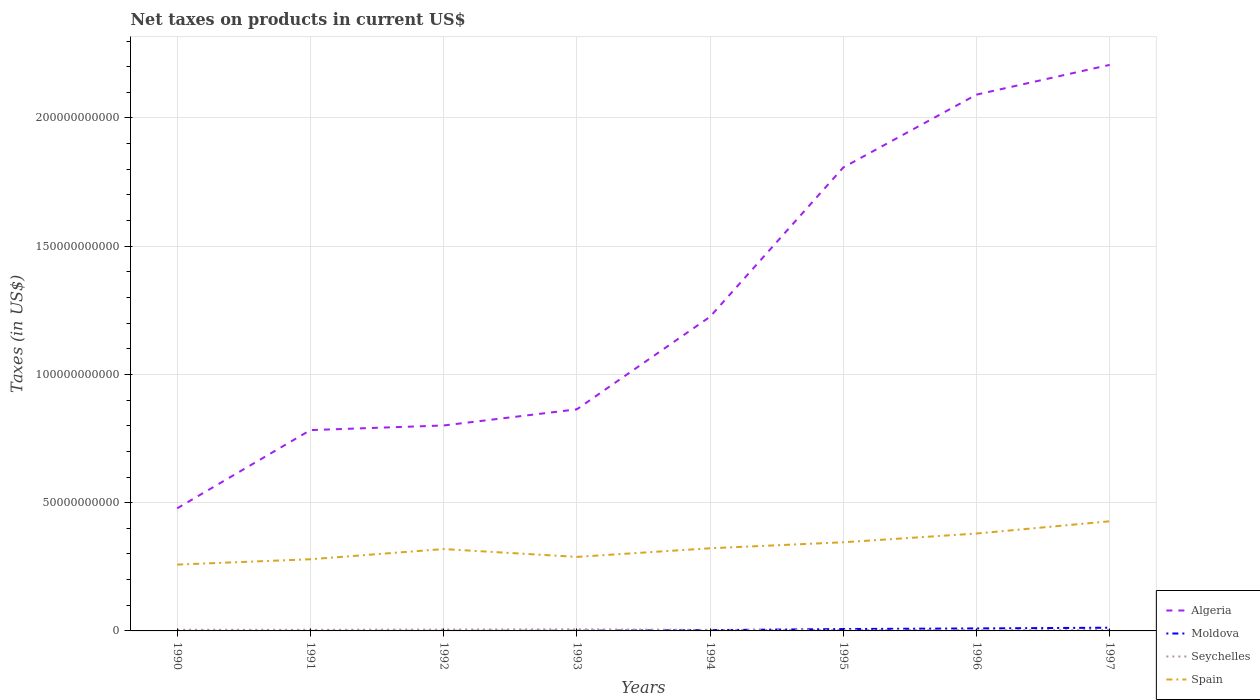Does the line corresponding to Algeria intersect with the line corresponding to Seychelles?
Offer a terse response. No. Is the number of lines equal to the number of legend labels?
Ensure brevity in your answer.  Yes. Across all years, what is the maximum net taxes on products in Moldova?
Your response must be concise. 7.11e+05. In which year was the net taxes on products in Algeria maximum?
Your answer should be very brief. 1990. What is the total net taxes on products in Moldova in the graph?
Give a very brief answer. -9.57e+08. What is the difference between the highest and the second highest net taxes on products in Seychelles?
Make the answer very short. 3.41e+08. Is the net taxes on products in Algeria strictly greater than the net taxes on products in Spain over the years?
Make the answer very short. No. What is the difference between two consecutive major ticks on the Y-axis?
Keep it short and to the point. 5.00e+1. Are the values on the major ticks of Y-axis written in scientific E-notation?
Provide a succinct answer. No. Does the graph contain any zero values?
Your answer should be very brief. No. How are the legend labels stacked?
Offer a very short reply. Vertical. What is the title of the graph?
Provide a succinct answer. Net taxes on products in current US$. What is the label or title of the Y-axis?
Give a very brief answer. Taxes (in US$). What is the Taxes (in US$) of Algeria in 1990?
Give a very brief answer. 4.78e+1. What is the Taxes (in US$) in Moldova in 1990?
Provide a short and direct response. 7.11e+05. What is the Taxes (in US$) of Seychelles in 1990?
Provide a short and direct response. 4.66e+08. What is the Taxes (in US$) of Spain in 1990?
Give a very brief answer. 2.59e+1. What is the Taxes (in US$) in Algeria in 1991?
Make the answer very short. 7.83e+1. What is the Taxes (in US$) of Moldova in 1991?
Provide a short and direct response. 2.50e+06. What is the Taxes (in US$) in Seychelles in 1991?
Provide a short and direct response. 4.37e+08. What is the Taxes (in US$) of Spain in 1991?
Your answer should be compact. 2.79e+1. What is the Taxes (in US$) in Algeria in 1992?
Offer a very short reply. 8.01e+1. What is the Taxes (in US$) of Moldova in 1992?
Provide a short and direct response. 1.50e+07. What is the Taxes (in US$) of Seychelles in 1992?
Offer a terse response. 5.37e+08. What is the Taxes (in US$) in Spain in 1992?
Give a very brief answer. 3.19e+1. What is the Taxes (in US$) in Algeria in 1993?
Offer a terse response. 8.64e+1. What is the Taxes (in US$) in Moldova in 1993?
Your answer should be very brief. 7.31e+07. What is the Taxes (in US$) in Seychelles in 1993?
Your answer should be very brief. 6.43e+08. What is the Taxes (in US$) of Spain in 1993?
Offer a very short reply. 2.89e+1. What is the Taxes (in US$) of Algeria in 1994?
Your response must be concise. 1.22e+11. What is the Taxes (in US$) of Moldova in 1994?
Provide a short and direct response. 3.12e+08. What is the Taxes (in US$) in Seychelles in 1994?
Provide a succinct answer. 3.99e+08. What is the Taxes (in US$) of Spain in 1994?
Provide a succinct answer. 3.22e+1. What is the Taxes (in US$) of Algeria in 1995?
Offer a very short reply. 1.81e+11. What is the Taxes (in US$) of Moldova in 1995?
Offer a very short reply. 7.36e+08. What is the Taxes (in US$) in Seychelles in 1995?
Offer a very short reply. 3.02e+08. What is the Taxes (in US$) in Spain in 1995?
Offer a very short reply. 3.46e+1. What is the Taxes (in US$) in Algeria in 1996?
Your answer should be very brief. 2.09e+11. What is the Taxes (in US$) in Moldova in 1996?
Your answer should be compact. 9.72e+08. What is the Taxes (in US$) of Seychelles in 1996?
Keep it short and to the point. 3.06e+08. What is the Taxes (in US$) of Spain in 1996?
Keep it short and to the point. 3.80e+1. What is the Taxes (in US$) of Algeria in 1997?
Offer a terse response. 2.21e+11. What is the Taxes (in US$) in Moldova in 1997?
Give a very brief answer. 1.25e+09. What is the Taxes (in US$) in Seychelles in 1997?
Ensure brevity in your answer.  3.22e+08. What is the Taxes (in US$) in Spain in 1997?
Your response must be concise. 4.27e+1. Across all years, what is the maximum Taxes (in US$) of Algeria?
Your response must be concise. 2.21e+11. Across all years, what is the maximum Taxes (in US$) in Moldova?
Make the answer very short. 1.25e+09. Across all years, what is the maximum Taxes (in US$) in Seychelles?
Ensure brevity in your answer.  6.43e+08. Across all years, what is the maximum Taxes (in US$) in Spain?
Your answer should be very brief. 4.27e+1. Across all years, what is the minimum Taxes (in US$) in Algeria?
Keep it short and to the point. 4.78e+1. Across all years, what is the minimum Taxes (in US$) in Moldova?
Your response must be concise. 7.11e+05. Across all years, what is the minimum Taxes (in US$) of Seychelles?
Offer a very short reply. 3.02e+08. Across all years, what is the minimum Taxes (in US$) in Spain?
Provide a short and direct response. 2.59e+1. What is the total Taxes (in US$) of Algeria in the graph?
Keep it short and to the point. 1.03e+12. What is the total Taxes (in US$) of Moldova in the graph?
Offer a terse response. 3.36e+09. What is the total Taxes (in US$) in Seychelles in the graph?
Offer a very short reply. 3.41e+09. What is the total Taxes (in US$) in Spain in the graph?
Make the answer very short. 2.62e+11. What is the difference between the Taxes (in US$) of Algeria in 1990 and that in 1991?
Offer a very short reply. -3.05e+1. What is the difference between the Taxes (in US$) in Moldova in 1990 and that in 1991?
Your answer should be compact. -1.79e+06. What is the difference between the Taxes (in US$) in Seychelles in 1990 and that in 1991?
Provide a succinct answer. 2.95e+07. What is the difference between the Taxes (in US$) in Spain in 1990 and that in 1991?
Your answer should be very brief. -2.08e+09. What is the difference between the Taxes (in US$) of Algeria in 1990 and that in 1992?
Offer a terse response. -3.23e+1. What is the difference between the Taxes (in US$) in Moldova in 1990 and that in 1992?
Give a very brief answer. -1.43e+07. What is the difference between the Taxes (in US$) in Seychelles in 1990 and that in 1992?
Your response must be concise. -7.12e+07. What is the difference between the Taxes (in US$) of Spain in 1990 and that in 1992?
Provide a succinct answer. -6.06e+09. What is the difference between the Taxes (in US$) of Algeria in 1990 and that in 1993?
Keep it short and to the point. -3.86e+1. What is the difference between the Taxes (in US$) of Moldova in 1990 and that in 1993?
Provide a short and direct response. -7.24e+07. What is the difference between the Taxes (in US$) in Seychelles in 1990 and that in 1993?
Your answer should be compact. -1.76e+08. What is the difference between the Taxes (in US$) in Spain in 1990 and that in 1993?
Provide a short and direct response. -3.00e+09. What is the difference between the Taxes (in US$) of Algeria in 1990 and that in 1994?
Ensure brevity in your answer.  -7.47e+1. What is the difference between the Taxes (in US$) in Moldova in 1990 and that in 1994?
Offer a terse response. -3.11e+08. What is the difference between the Taxes (in US$) of Seychelles in 1990 and that in 1994?
Ensure brevity in your answer.  6.71e+07. What is the difference between the Taxes (in US$) in Spain in 1990 and that in 1994?
Your response must be concise. -6.36e+09. What is the difference between the Taxes (in US$) in Algeria in 1990 and that in 1995?
Offer a very short reply. -1.33e+11. What is the difference between the Taxes (in US$) in Moldova in 1990 and that in 1995?
Ensure brevity in your answer.  -7.35e+08. What is the difference between the Taxes (in US$) of Seychelles in 1990 and that in 1995?
Offer a very short reply. 1.64e+08. What is the difference between the Taxes (in US$) in Spain in 1990 and that in 1995?
Offer a very short reply. -8.70e+09. What is the difference between the Taxes (in US$) of Algeria in 1990 and that in 1996?
Your answer should be very brief. -1.61e+11. What is the difference between the Taxes (in US$) in Moldova in 1990 and that in 1996?
Ensure brevity in your answer.  -9.71e+08. What is the difference between the Taxes (in US$) of Seychelles in 1990 and that in 1996?
Give a very brief answer. 1.60e+08. What is the difference between the Taxes (in US$) of Spain in 1990 and that in 1996?
Offer a very short reply. -1.21e+1. What is the difference between the Taxes (in US$) of Algeria in 1990 and that in 1997?
Make the answer very short. -1.73e+11. What is the difference between the Taxes (in US$) of Moldova in 1990 and that in 1997?
Make the answer very short. -1.25e+09. What is the difference between the Taxes (in US$) of Seychelles in 1990 and that in 1997?
Keep it short and to the point. 1.44e+08. What is the difference between the Taxes (in US$) of Spain in 1990 and that in 1997?
Provide a succinct answer. -1.69e+1. What is the difference between the Taxes (in US$) in Algeria in 1991 and that in 1992?
Provide a short and direct response. -1.80e+09. What is the difference between the Taxes (in US$) of Moldova in 1991 and that in 1992?
Keep it short and to the point. -1.25e+07. What is the difference between the Taxes (in US$) of Seychelles in 1991 and that in 1992?
Ensure brevity in your answer.  -1.01e+08. What is the difference between the Taxes (in US$) in Spain in 1991 and that in 1992?
Provide a succinct answer. -3.97e+09. What is the difference between the Taxes (in US$) in Algeria in 1991 and that in 1993?
Provide a succinct answer. -8.10e+09. What is the difference between the Taxes (in US$) of Moldova in 1991 and that in 1993?
Keep it short and to the point. -7.06e+07. What is the difference between the Taxes (in US$) of Seychelles in 1991 and that in 1993?
Give a very brief answer. -2.06e+08. What is the difference between the Taxes (in US$) in Spain in 1991 and that in 1993?
Give a very brief answer. -9.21e+08. What is the difference between the Taxes (in US$) in Algeria in 1991 and that in 1994?
Your answer should be compact. -4.42e+1. What is the difference between the Taxes (in US$) in Moldova in 1991 and that in 1994?
Your response must be concise. -3.09e+08. What is the difference between the Taxes (in US$) in Seychelles in 1991 and that in 1994?
Give a very brief answer. 3.76e+07. What is the difference between the Taxes (in US$) of Spain in 1991 and that in 1994?
Give a very brief answer. -4.28e+09. What is the difference between the Taxes (in US$) in Algeria in 1991 and that in 1995?
Provide a succinct answer. -1.02e+11. What is the difference between the Taxes (in US$) of Moldova in 1991 and that in 1995?
Offer a terse response. -7.33e+08. What is the difference between the Taxes (in US$) in Seychelles in 1991 and that in 1995?
Offer a terse response. 1.35e+08. What is the difference between the Taxes (in US$) in Spain in 1991 and that in 1995?
Ensure brevity in your answer.  -6.62e+09. What is the difference between the Taxes (in US$) of Algeria in 1991 and that in 1996?
Your answer should be compact. -1.31e+11. What is the difference between the Taxes (in US$) in Moldova in 1991 and that in 1996?
Provide a short and direct response. -9.69e+08. What is the difference between the Taxes (in US$) of Seychelles in 1991 and that in 1996?
Ensure brevity in your answer.  1.30e+08. What is the difference between the Taxes (in US$) in Spain in 1991 and that in 1996?
Ensure brevity in your answer.  -1.00e+1. What is the difference between the Taxes (in US$) in Algeria in 1991 and that in 1997?
Your answer should be compact. -1.42e+11. What is the difference between the Taxes (in US$) in Moldova in 1991 and that in 1997?
Provide a succinct answer. -1.25e+09. What is the difference between the Taxes (in US$) in Seychelles in 1991 and that in 1997?
Your response must be concise. 1.15e+08. What is the difference between the Taxes (in US$) of Spain in 1991 and that in 1997?
Your answer should be very brief. -1.48e+1. What is the difference between the Taxes (in US$) in Algeria in 1992 and that in 1993?
Keep it short and to the point. -6.30e+09. What is the difference between the Taxes (in US$) in Moldova in 1992 and that in 1993?
Offer a terse response. -5.81e+07. What is the difference between the Taxes (in US$) of Seychelles in 1992 and that in 1993?
Provide a short and direct response. -1.05e+08. What is the difference between the Taxes (in US$) of Spain in 1992 and that in 1993?
Ensure brevity in your answer.  3.05e+09. What is the difference between the Taxes (in US$) in Algeria in 1992 and that in 1994?
Provide a short and direct response. -4.24e+1. What is the difference between the Taxes (in US$) of Moldova in 1992 and that in 1994?
Provide a succinct answer. -2.97e+08. What is the difference between the Taxes (in US$) in Seychelles in 1992 and that in 1994?
Give a very brief answer. 1.38e+08. What is the difference between the Taxes (in US$) in Spain in 1992 and that in 1994?
Provide a succinct answer. -3.05e+08. What is the difference between the Taxes (in US$) of Algeria in 1992 and that in 1995?
Your response must be concise. -1.01e+11. What is the difference between the Taxes (in US$) of Moldova in 1992 and that in 1995?
Offer a very short reply. -7.21e+08. What is the difference between the Taxes (in US$) of Seychelles in 1992 and that in 1995?
Your response must be concise. 2.35e+08. What is the difference between the Taxes (in US$) in Spain in 1992 and that in 1995?
Provide a short and direct response. -2.65e+09. What is the difference between the Taxes (in US$) of Algeria in 1992 and that in 1996?
Provide a short and direct response. -1.29e+11. What is the difference between the Taxes (in US$) in Moldova in 1992 and that in 1996?
Your response must be concise. -9.57e+08. What is the difference between the Taxes (in US$) in Seychelles in 1992 and that in 1996?
Give a very brief answer. 2.31e+08. What is the difference between the Taxes (in US$) of Spain in 1992 and that in 1996?
Your response must be concise. -6.05e+09. What is the difference between the Taxes (in US$) in Algeria in 1992 and that in 1997?
Ensure brevity in your answer.  -1.41e+11. What is the difference between the Taxes (in US$) in Moldova in 1992 and that in 1997?
Keep it short and to the point. -1.24e+09. What is the difference between the Taxes (in US$) of Seychelles in 1992 and that in 1997?
Your answer should be compact. 2.16e+08. What is the difference between the Taxes (in US$) in Spain in 1992 and that in 1997?
Offer a very short reply. -1.08e+1. What is the difference between the Taxes (in US$) of Algeria in 1993 and that in 1994?
Provide a short and direct response. -3.61e+1. What is the difference between the Taxes (in US$) of Moldova in 1993 and that in 1994?
Your response must be concise. -2.38e+08. What is the difference between the Taxes (in US$) of Seychelles in 1993 and that in 1994?
Provide a succinct answer. 2.44e+08. What is the difference between the Taxes (in US$) of Spain in 1993 and that in 1994?
Your answer should be compact. -3.36e+09. What is the difference between the Taxes (in US$) in Algeria in 1993 and that in 1995?
Provide a short and direct response. -9.43e+1. What is the difference between the Taxes (in US$) of Moldova in 1993 and that in 1995?
Provide a short and direct response. -6.62e+08. What is the difference between the Taxes (in US$) of Seychelles in 1993 and that in 1995?
Provide a succinct answer. 3.41e+08. What is the difference between the Taxes (in US$) in Spain in 1993 and that in 1995?
Offer a very short reply. -5.70e+09. What is the difference between the Taxes (in US$) in Algeria in 1993 and that in 1996?
Your answer should be compact. -1.23e+11. What is the difference between the Taxes (in US$) in Moldova in 1993 and that in 1996?
Provide a short and direct response. -8.99e+08. What is the difference between the Taxes (in US$) in Seychelles in 1993 and that in 1996?
Offer a terse response. 3.36e+08. What is the difference between the Taxes (in US$) in Spain in 1993 and that in 1996?
Your answer should be very brief. -9.11e+09. What is the difference between the Taxes (in US$) of Algeria in 1993 and that in 1997?
Your answer should be compact. -1.34e+11. What is the difference between the Taxes (in US$) in Moldova in 1993 and that in 1997?
Give a very brief answer. -1.18e+09. What is the difference between the Taxes (in US$) in Seychelles in 1993 and that in 1997?
Your answer should be compact. 3.21e+08. What is the difference between the Taxes (in US$) of Spain in 1993 and that in 1997?
Offer a very short reply. -1.39e+1. What is the difference between the Taxes (in US$) in Algeria in 1994 and that in 1995?
Provide a short and direct response. -5.82e+1. What is the difference between the Taxes (in US$) in Moldova in 1994 and that in 1995?
Keep it short and to the point. -4.24e+08. What is the difference between the Taxes (in US$) in Seychelles in 1994 and that in 1995?
Provide a succinct answer. 9.71e+07. What is the difference between the Taxes (in US$) in Spain in 1994 and that in 1995?
Your response must be concise. -2.34e+09. What is the difference between the Taxes (in US$) in Algeria in 1994 and that in 1996?
Offer a very short reply. -8.66e+1. What is the difference between the Taxes (in US$) of Moldova in 1994 and that in 1996?
Give a very brief answer. -6.60e+08. What is the difference between the Taxes (in US$) of Seychelles in 1994 and that in 1996?
Your answer should be very brief. 9.28e+07. What is the difference between the Taxes (in US$) in Spain in 1994 and that in 1996?
Make the answer very short. -5.75e+09. What is the difference between the Taxes (in US$) of Algeria in 1994 and that in 1997?
Your answer should be very brief. -9.82e+1. What is the difference between the Taxes (in US$) in Moldova in 1994 and that in 1997?
Keep it short and to the point. -9.41e+08. What is the difference between the Taxes (in US$) in Seychelles in 1994 and that in 1997?
Provide a short and direct response. 7.74e+07. What is the difference between the Taxes (in US$) of Spain in 1994 and that in 1997?
Keep it short and to the point. -1.05e+1. What is the difference between the Taxes (in US$) in Algeria in 1995 and that in 1996?
Your answer should be compact. -2.84e+1. What is the difference between the Taxes (in US$) in Moldova in 1995 and that in 1996?
Give a very brief answer. -2.36e+08. What is the difference between the Taxes (in US$) in Seychelles in 1995 and that in 1996?
Your response must be concise. -4.30e+06. What is the difference between the Taxes (in US$) in Spain in 1995 and that in 1996?
Make the answer very short. -3.41e+09. What is the difference between the Taxes (in US$) of Algeria in 1995 and that in 1997?
Offer a very short reply. -4.00e+1. What is the difference between the Taxes (in US$) in Moldova in 1995 and that in 1997?
Keep it short and to the point. -5.17e+08. What is the difference between the Taxes (in US$) in Seychelles in 1995 and that in 1997?
Your answer should be compact. -1.97e+07. What is the difference between the Taxes (in US$) of Spain in 1995 and that in 1997?
Provide a succinct answer. -8.18e+09. What is the difference between the Taxes (in US$) of Algeria in 1996 and that in 1997?
Ensure brevity in your answer.  -1.16e+1. What is the difference between the Taxes (in US$) in Moldova in 1996 and that in 1997?
Make the answer very short. -2.81e+08. What is the difference between the Taxes (in US$) in Seychelles in 1996 and that in 1997?
Provide a short and direct response. -1.54e+07. What is the difference between the Taxes (in US$) in Spain in 1996 and that in 1997?
Make the answer very short. -4.78e+09. What is the difference between the Taxes (in US$) in Algeria in 1990 and the Taxes (in US$) in Moldova in 1991?
Your response must be concise. 4.78e+1. What is the difference between the Taxes (in US$) of Algeria in 1990 and the Taxes (in US$) of Seychelles in 1991?
Ensure brevity in your answer.  4.74e+1. What is the difference between the Taxes (in US$) of Algeria in 1990 and the Taxes (in US$) of Spain in 1991?
Provide a short and direct response. 1.99e+1. What is the difference between the Taxes (in US$) of Moldova in 1990 and the Taxes (in US$) of Seychelles in 1991?
Make the answer very short. -4.36e+08. What is the difference between the Taxes (in US$) in Moldova in 1990 and the Taxes (in US$) in Spain in 1991?
Make the answer very short. -2.79e+1. What is the difference between the Taxes (in US$) of Seychelles in 1990 and the Taxes (in US$) of Spain in 1991?
Your response must be concise. -2.75e+1. What is the difference between the Taxes (in US$) in Algeria in 1990 and the Taxes (in US$) in Moldova in 1992?
Keep it short and to the point. 4.78e+1. What is the difference between the Taxes (in US$) in Algeria in 1990 and the Taxes (in US$) in Seychelles in 1992?
Give a very brief answer. 4.73e+1. What is the difference between the Taxes (in US$) of Algeria in 1990 and the Taxes (in US$) of Spain in 1992?
Keep it short and to the point. 1.59e+1. What is the difference between the Taxes (in US$) in Moldova in 1990 and the Taxes (in US$) in Seychelles in 1992?
Provide a succinct answer. -5.37e+08. What is the difference between the Taxes (in US$) of Moldova in 1990 and the Taxes (in US$) of Spain in 1992?
Your answer should be very brief. -3.19e+1. What is the difference between the Taxes (in US$) in Seychelles in 1990 and the Taxes (in US$) in Spain in 1992?
Offer a very short reply. -3.15e+1. What is the difference between the Taxes (in US$) in Algeria in 1990 and the Taxes (in US$) in Moldova in 1993?
Keep it short and to the point. 4.77e+1. What is the difference between the Taxes (in US$) of Algeria in 1990 and the Taxes (in US$) of Seychelles in 1993?
Offer a very short reply. 4.72e+1. What is the difference between the Taxes (in US$) of Algeria in 1990 and the Taxes (in US$) of Spain in 1993?
Make the answer very short. 1.89e+1. What is the difference between the Taxes (in US$) in Moldova in 1990 and the Taxes (in US$) in Seychelles in 1993?
Your answer should be compact. -6.42e+08. What is the difference between the Taxes (in US$) in Moldova in 1990 and the Taxes (in US$) in Spain in 1993?
Provide a short and direct response. -2.89e+1. What is the difference between the Taxes (in US$) of Seychelles in 1990 and the Taxes (in US$) of Spain in 1993?
Offer a terse response. -2.84e+1. What is the difference between the Taxes (in US$) in Algeria in 1990 and the Taxes (in US$) in Moldova in 1994?
Your answer should be very brief. 4.75e+1. What is the difference between the Taxes (in US$) in Algeria in 1990 and the Taxes (in US$) in Seychelles in 1994?
Ensure brevity in your answer.  4.74e+1. What is the difference between the Taxes (in US$) in Algeria in 1990 and the Taxes (in US$) in Spain in 1994?
Offer a terse response. 1.56e+1. What is the difference between the Taxes (in US$) in Moldova in 1990 and the Taxes (in US$) in Seychelles in 1994?
Provide a succinct answer. -3.98e+08. What is the difference between the Taxes (in US$) in Moldova in 1990 and the Taxes (in US$) in Spain in 1994?
Your answer should be very brief. -3.22e+1. What is the difference between the Taxes (in US$) in Seychelles in 1990 and the Taxes (in US$) in Spain in 1994?
Provide a short and direct response. -3.18e+1. What is the difference between the Taxes (in US$) in Algeria in 1990 and the Taxes (in US$) in Moldova in 1995?
Make the answer very short. 4.71e+1. What is the difference between the Taxes (in US$) of Algeria in 1990 and the Taxes (in US$) of Seychelles in 1995?
Make the answer very short. 4.75e+1. What is the difference between the Taxes (in US$) of Algeria in 1990 and the Taxes (in US$) of Spain in 1995?
Provide a succinct answer. 1.32e+1. What is the difference between the Taxes (in US$) in Moldova in 1990 and the Taxes (in US$) in Seychelles in 1995?
Your response must be concise. -3.01e+08. What is the difference between the Taxes (in US$) of Moldova in 1990 and the Taxes (in US$) of Spain in 1995?
Your answer should be compact. -3.46e+1. What is the difference between the Taxes (in US$) in Seychelles in 1990 and the Taxes (in US$) in Spain in 1995?
Provide a succinct answer. -3.41e+1. What is the difference between the Taxes (in US$) of Algeria in 1990 and the Taxes (in US$) of Moldova in 1996?
Make the answer very short. 4.68e+1. What is the difference between the Taxes (in US$) of Algeria in 1990 and the Taxes (in US$) of Seychelles in 1996?
Your response must be concise. 4.75e+1. What is the difference between the Taxes (in US$) in Algeria in 1990 and the Taxes (in US$) in Spain in 1996?
Offer a terse response. 9.83e+09. What is the difference between the Taxes (in US$) of Moldova in 1990 and the Taxes (in US$) of Seychelles in 1996?
Your answer should be very brief. -3.06e+08. What is the difference between the Taxes (in US$) of Moldova in 1990 and the Taxes (in US$) of Spain in 1996?
Make the answer very short. -3.80e+1. What is the difference between the Taxes (in US$) in Seychelles in 1990 and the Taxes (in US$) in Spain in 1996?
Your answer should be very brief. -3.75e+1. What is the difference between the Taxes (in US$) in Algeria in 1990 and the Taxes (in US$) in Moldova in 1997?
Provide a succinct answer. 4.65e+1. What is the difference between the Taxes (in US$) of Algeria in 1990 and the Taxes (in US$) of Seychelles in 1997?
Make the answer very short. 4.75e+1. What is the difference between the Taxes (in US$) of Algeria in 1990 and the Taxes (in US$) of Spain in 1997?
Your answer should be very brief. 5.05e+09. What is the difference between the Taxes (in US$) in Moldova in 1990 and the Taxes (in US$) in Seychelles in 1997?
Your response must be concise. -3.21e+08. What is the difference between the Taxes (in US$) of Moldova in 1990 and the Taxes (in US$) of Spain in 1997?
Give a very brief answer. -4.27e+1. What is the difference between the Taxes (in US$) of Seychelles in 1990 and the Taxes (in US$) of Spain in 1997?
Keep it short and to the point. -4.23e+1. What is the difference between the Taxes (in US$) of Algeria in 1991 and the Taxes (in US$) of Moldova in 1992?
Your response must be concise. 7.83e+1. What is the difference between the Taxes (in US$) in Algeria in 1991 and the Taxes (in US$) in Seychelles in 1992?
Your response must be concise. 7.78e+1. What is the difference between the Taxes (in US$) of Algeria in 1991 and the Taxes (in US$) of Spain in 1992?
Offer a terse response. 4.64e+1. What is the difference between the Taxes (in US$) in Moldova in 1991 and the Taxes (in US$) in Seychelles in 1992?
Make the answer very short. -5.35e+08. What is the difference between the Taxes (in US$) of Moldova in 1991 and the Taxes (in US$) of Spain in 1992?
Make the answer very short. -3.19e+1. What is the difference between the Taxes (in US$) in Seychelles in 1991 and the Taxes (in US$) in Spain in 1992?
Offer a terse response. -3.15e+1. What is the difference between the Taxes (in US$) in Algeria in 1991 and the Taxes (in US$) in Moldova in 1993?
Your response must be concise. 7.82e+1. What is the difference between the Taxes (in US$) in Algeria in 1991 and the Taxes (in US$) in Seychelles in 1993?
Ensure brevity in your answer.  7.77e+1. What is the difference between the Taxes (in US$) of Algeria in 1991 and the Taxes (in US$) of Spain in 1993?
Ensure brevity in your answer.  4.94e+1. What is the difference between the Taxes (in US$) in Moldova in 1991 and the Taxes (in US$) in Seychelles in 1993?
Give a very brief answer. -6.40e+08. What is the difference between the Taxes (in US$) in Moldova in 1991 and the Taxes (in US$) in Spain in 1993?
Make the answer very short. -2.89e+1. What is the difference between the Taxes (in US$) in Seychelles in 1991 and the Taxes (in US$) in Spain in 1993?
Provide a short and direct response. -2.84e+1. What is the difference between the Taxes (in US$) in Algeria in 1991 and the Taxes (in US$) in Moldova in 1994?
Give a very brief answer. 7.80e+1. What is the difference between the Taxes (in US$) in Algeria in 1991 and the Taxes (in US$) in Seychelles in 1994?
Give a very brief answer. 7.79e+1. What is the difference between the Taxes (in US$) of Algeria in 1991 and the Taxes (in US$) of Spain in 1994?
Offer a terse response. 4.61e+1. What is the difference between the Taxes (in US$) in Moldova in 1991 and the Taxes (in US$) in Seychelles in 1994?
Offer a terse response. -3.97e+08. What is the difference between the Taxes (in US$) in Moldova in 1991 and the Taxes (in US$) in Spain in 1994?
Provide a succinct answer. -3.22e+1. What is the difference between the Taxes (in US$) of Seychelles in 1991 and the Taxes (in US$) of Spain in 1994?
Your response must be concise. -3.18e+1. What is the difference between the Taxes (in US$) in Algeria in 1991 and the Taxes (in US$) in Moldova in 1995?
Offer a terse response. 7.76e+1. What is the difference between the Taxes (in US$) in Algeria in 1991 and the Taxes (in US$) in Seychelles in 1995?
Offer a very short reply. 7.80e+1. What is the difference between the Taxes (in US$) of Algeria in 1991 and the Taxes (in US$) of Spain in 1995?
Your response must be concise. 4.37e+1. What is the difference between the Taxes (in US$) in Moldova in 1991 and the Taxes (in US$) in Seychelles in 1995?
Ensure brevity in your answer.  -3.00e+08. What is the difference between the Taxes (in US$) of Moldova in 1991 and the Taxes (in US$) of Spain in 1995?
Offer a terse response. -3.46e+1. What is the difference between the Taxes (in US$) in Seychelles in 1991 and the Taxes (in US$) in Spain in 1995?
Keep it short and to the point. -3.41e+1. What is the difference between the Taxes (in US$) in Algeria in 1991 and the Taxes (in US$) in Moldova in 1996?
Provide a short and direct response. 7.73e+1. What is the difference between the Taxes (in US$) of Algeria in 1991 and the Taxes (in US$) of Seychelles in 1996?
Provide a succinct answer. 7.80e+1. What is the difference between the Taxes (in US$) in Algeria in 1991 and the Taxes (in US$) in Spain in 1996?
Your answer should be compact. 4.03e+1. What is the difference between the Taxes (in US$) in Moldova in 1991 and the Taxes (in US$) in Seychelles in 1996?
Keep it short and to the point. -3.04e+08. What is the difference between the Taxes (in US$) of Moldova in 1991 and the Taxes (in US$) of Spain in 1996?
Give a very brief answer. -3.80e+1. What is the difference between the Taxes (in US$) in Seychelles in 1991 and the Taxes (in US$) in Spain in 1996?
Make the answer very short. -3.75e+1. What is the difference between the Taxes (in US$) in Algeria in 1991 and the Taxes (in US$) in Moldova in 1997?
Ensure brevity in your answer.  7.70e+1. What is the difference between the Taxes (in US$) of Algeria in 1991 and the Taxes (in US$) of Seychelles in 1997?
Your answer should be compact. 7.80e+1. What is the difference between the Taxes (in US$) of Algeria in 1991 and the Taxes (in US$) of Spain in 1997?
Give a very brief answer. 3.56e+1. What is the difference between the Taxes (in US$) in Moldova in 1991 and the Taxes (in US$) in Seychelles in 1997?
Your response must be concise. -3.19e+08. What is the difference between the Taxes (in US$) in Moldova in 1991 and the Taxes (in US$) in Spain in 1997?
Keep it short and to the point. -4.27e+1. What is the difference between the Taxes (in US$) in Seychelles in 1991 and the Taxes (in US$) in Spain in 1997?
Ensure brevity in your answer.  -4.23e+1. What is the difference between the Taxes (in US$) in Algeria in 1992 and the Taxes (in US$) in Moldova in 1993?
Give a very brief answer. 8.00e+1. What is the difference between the Taxes (in US$) in Algeria in 1992 and the Taxes (in US$) in Seychelles in 1993?
Provide a succinct answer. 7.95e+1. What is the difference between the Taxes (in US$) in Algeria in 1992 and the Taxes (in US$) in Spain in 1993?
Your answer should be compact. 5.12e+1. What is the difference between the Taxes (in US$) in Moldova in 1992 and the Taxes (in US$) in Seychelles in 1993?
Keep it short and to the point. -6.28e+08. What is the difference between the Taxes (in US$) of Moldova in 1992 and the Taxes (in US$) of Spain in 1993?
Make the answer very short. -2.88e+1. What is the difference between the Taxes (in US$) of Seychelles in 1992 and the Taxes (in US$) of Spain in 1993?
Provide a short and direct response. -2.83e+1. What is the difference between the Taxes (in US$) of Algeria in 1992 and the Taxes (in US$) of Moldova in 1994?
Give a very brief answer. 7.98e+1. What is the difference between the Taxes (in US$) in Algeria in 1992 and the Taxes (in US$) in Seychelles in 1994?
Offer a very short reply. 7.97e+1. What is the difference between the Taxes (in US$) in Algeria in 1992 and the Taxes (in US$) in Spain in 1994?
Make the answer very short. 4.79e+1. What is the difference between the Taxes (in US$) in Moldova in 1992 and the Taxes (in US$) in Seychelles in 1994?
Your answer should be very brief. -3.84e+08. What is the difference between the Taxes (in US$) of Moldova in 1992 and the Taxes (in US$) of Spain in 1994?
Keep it short and to the point. -3.22e+1. What is the difference between the Taxes (in US$) of Seychelles in 1992 and the Taxes (in US$) of Spain in 1994?
Ensure brevity in your answer.  -3.17e+1. What is the difference between the Taxes (in US$) of Algeria in 1992 and the Taxes (in US$) of Moldova in 1995?
Give a very brief answer. 7.94e+1. What is the difference between the Taxes (in US$) of Algeria in 1992 and the Taxes (in US$) of Seychelles in 1995?
Ensure brevity in your answer.  7.98e+1. What is the difference between the Taxes (in US$) in Algeria in 1992 and the Taxes (in US$) in Spain in 1995?
Offer a very short reply. 4.55e+1. What is the difference between the Taxes (in US$) of Moldova in 1992 and the Taxes (in US$) of Seychelles in 1995?
Give a very brief answer. -2.87e+08. What is the difference between the Taxes (in US$) of Moldova in 1992 and the Taxes (in US$) of Spain in 1995?
Provide a succinct answer. -3.46e+1. What is the difference between the Taxes (in US$) of Seychelles in 1992 and the Taxes (in US$) of Spain in 1995?
Offer a very short reply. -3.40e+1. What is the difference between the Taxes (in US$) of Algeria in 1992 and the Taxes (in US$) of Moldova in 1996?
Your answer should be compact. 7.91e+1. What is the difference between the Taxes (in US$) of Algeria in 1992 and the Taxes (in US$) of Seychelles in 1996?
Ensure brevity in your answer.  7.98e+1. What is the difference between the Taxes (in US$) in Algeria in 1992 and the Taxes (in US$) in Spain in 1996?
Offer a terse response. 4.21e+1. What is the difference between the Taxes (in US$) in Moldova in 1992 and the Taxes (in US$) in Seychelles in 1996?
Make the answer very short. -2.91e+08. What is the difference between the Taxes (in US$) in Moldova in 1992 and the Taxes (in US$) in Spain in 1996?
Make the answer very short. -3.80e+1. What is the difference between the Taxes (in US$) of Seychelles in 1992 and the Taxes (in US$) of Spain in 1996?
Make the answer very short. -3.74e+1. What is the difference between the Taxes (in US$) in Algeria in 1992 and the Taxes (in US$) in Moldova in 1997?
Your answer should be compact. 7.88e+1. What is the difference between the Taxes (in US$) in Algeria in 1992 and the Taxes (in US$) in Seychelles in 1997?
Your answer should be compact. 7.98e+1. What is the difference between the Taxes (in US$) in Algeria in 1992 and the Taxes (in US$) in Spain in 1997?
Provide a short and direct response. 3.74e+1. What is the difference between the Taxes (in US$) in Moldova in 1992 and the Taxes (in US$) in Seychelles in 1997?
Offer a very short reply. -3.07e+08. What is the difference between the Taxes (in US$) in Moldova in 1992 and the Taxes (in US$) in Spain in 1997?
Keep it short and to the point. -4.27e+1. What is the difference between the Taxes (in US$) in Seychelles in 1992 and the Taxes (in US$) in Spain in 1997?
Provide a short and direct response. -4.22e+1. What is the difference between the Taxes (in US$) in Algeria in 1993 and the Taxes (in US$) in Moldova in 1994?
Offer a very short reply. 8.61e+1. What is the difference between the Taxes (in US$) of Algeria in 1993 and the Taxes (in US$) of Seychelles in 1994?
Offer a terse response. 8.60e+1. What is the difference between the Taxes (in US$) of Algeria in 1993 and the Taxes (in US$) of Spain in 1994?
Your answer should be very brief. 5.42e+1. What is the difference between the Taxes (in US$) in Moldova in 1993 and the Taxes (in US$) in Seychelles in 1994?
Offer a very short reply. -3.26e+08. What is the difference between the Taxes (in US$) of Moldova in 1993 and the Taxes (in US$) of Spain in 1994?
Give a very brief answer. -3.21e+1. What is the difference between the Taxes (in US$) in Seychelles in 1993 and the Taxes (in US$) in Spain in 1994?
Make the answer very short. -3.16e+1. What is the difference between the Taxes (in US$) in Algeria in 1993 and the Taxes (in US$) in Moldova in 1995?
Give a very brief answer. 8.57e+1. What is the difference between the Taxes (in US$) in Algeria in 1993 and the Taxes (in US$) in Seychelles in 1995?
Your answer should be very brief. 8.61e+1. What is the difference between the Taxes (in US$) of Algeria in 1993 and the Taxes (in US$) of Spain in 1995?
Make the answer very short. 5.18e+1. What is the difference between the Taxes (in US$) in Moldova in 1993 and the Taxes (in US$) in Seychelles in 1995?
Your answer should be very brief. -2.29e+08. What is the difference between the Taxes (in US$) of Moldova in 1993 and the Taxes (in US$) of Spain in 1995?
Keep it short and to the point. -3.45e+1. What is the difference between the Taxes (in US$) in Seychelles in 1993 and the Taxes (in US$) in Spain in 1995?
Your response must be concise. -3.39e+1. What is the difference between the Taxes (in US$) of Algeria in 1993 and the Taxes (in US$) of Moldova in 1996?
Provide a short and direct response. 8.54e+1. What is the difference between the Taxes (in US$) of Algeria in 1993 and the Taxes (in US$) of Seychelles in 1996?
Provide a succinct answer. 8.61e+1. What is the difference between the Taxes (in US$) of Algeria in 1993 and the Taxes (in US$) of Spain in 1996?
Offer a terse response. 4.84e+1. What is the difference between the Taxes (in US$) of Moldova in 1993 and the Taxes (in US$) of Seychelles in 1996?
Provide a succinct answer. -2.33e+08. What is the difference between the Taxes (in US$) of Moldova in 1993 and the Taxes (in US$) of Spain in 1996?
Your answer should be compact. -3.79e+1. What is the difference between the Taxes (in US$) in Seychelles in 1993 and the Taxes (in US$) in Spain in 1996?
Your answer should be very brief. -3.73e+1. What is the difference between the Taxes (in US$) in Algeria in 1993 and the Taxes (in US$) in Moldova in 1997?
Your answer should be compact. 8.51e+1. What is the difference between the Taxes (in US$) in Algeria in 1993 and the Taxes (in US$) in Seychelles in 1997?
Ensure brevity in your answer.  8.61e+1. What is the difference between the Taxes (in US$) in Algeria in 1993 and the Taxes (in US$) in Spain in 1997?
Offer a terse response. 4.37e+1. What is the difference between the Taxes (in US$) in Moldova in 1993 and the Taxes (in US$) in Seychelles in 1997?
Make the answer very short. -2.49e+08. What is the difference between the Taxes (in US$) in Moldova in 1993 and the Taxes (in US$) in Spain in 1997?
Your answer should be very brief. -4.27e+1. What is the difference between the Taxes (in US$) of Seychelles in 1993 and the Taxes (in US$) of Spain in 1997?
Keep it short and to the point. -4.21e+1. What is the difference between the Taxes (in US$) in Algeria in 1994 and the Taxes (in US$) in Moldova in 1995?
Keep it short and to the point. 1.22e+11. What is the difference between the Taxes (in US$) in Algeria in 1994 and the Taxes (in US$) in Seychelles in 1995?
Make the answer very short. 1.22e+11. What is the difference between the Taxes (in US$) of Algeria in 1994 and the Taxes (in US$) of Spain in 1995?
Provide a short and direct response. 8.79e+1. What is the difference between the Taxes (in US$) of Moldova in 1994 and the Taxes (in US$) of Seychelles in 1995?
Offer a terse response. 9.60e+06. What is the difference between the Taxes (in US$) in Moldova in 1994 and the Taxes (in US$) in Spain in 1995?
Provide a succinct answer. -3.43e+1. What is the difference between the Taxes (in US$) of Seychelles in 1994 and the Taxes (in US$) of Spain in 1995?
Your answer should be very brief. -3.42e+1. What is the difference between the Taxes (in US$) of Algeria in 1994 and the Taxes (in US$) of Moldova in 1996?
Provide a short and direct response. 1.22e+11. What is the difference between the Taxes (in US$) of Algeria in 1994 and the Taxes (in US$) of Seychelles in 1996?
Your answer should be very brief. 1.22e+11. What is the difference between the Taxes (in US$) in Algeria in 1994 and the Taxes (in US$) in Spain in 1996?
Provide a short and direct response. 8.45e+1. What is the difference between the Taxes (in US$) in Moldova in 1994 and the Taxes (in US$) in Seychelles in 1996?
Provide a short and direct response. 5.30e+06. What is the difference between the Taxes (in US$) of Moldova in 1994 and the Taxes (in US$) of Spain in 1996?
Provide a short and direct response. -3.77e+1. What is the difference between the Taxes (in US$) of Seychelles in 1994 and the Taxes (in US$) of Spain in 1996?
Your answer should be compact. -3.76e+1. What is the difference between the Taxes (in US$) in Algeria in 1994 and the Taxes (in US$) in Moldova in 1997?
Keep it short and to the point. 1.21e+11. What is the difference between the Taxes (in US$) of Algeria in 1994 and the Taxes (in US$) of Seychelles in 1997?
Give a very brief answer. 1.22e+11. What is the difference between the Taxes (in US$) in Algeria in 1994 and the Taxes (in US$) in Spain in 1997?
Make the answer very short. 7.98e+1. What is the difference between the Taxes (in US$) in Moldova in 1994 and the Taxes (in US$) in Seychelles in 1997?
Your response must be concise. -1.01e+07. What is the difference between the Taxes (in US$) of Moldova in 1994 and the Taxes (in US$) of Spain in 1997?
Ensure brevity in your answer.  -4.24e+1. What is the difference between the Taxes (in US$) of Seychelles in 1994 and the Taxes (in US$) of Spain in 1997?
Offer a terse response. -4.23e+1. What is the difference between the Taxes (in US$) of Algeria in 1995 and the Taxes (in US$) of Moldova in 1996?
Ensure brevity in your answer.  1.80e+11. What is the difference between the Taxes (in US$) in Algeria in 1995 and the Taxes (in US$) in Seychelles in 1996?
Keep it short and to the point. 1.80e+11. What is the difference between the Taxes (in US$) of Algeria in 1995 and the Taxes (in US$) of Spain in 1996?
Provide a succinct answer. 1.43e+11. What is the difference between the Taxes (in US$) of Moldova in 1995 and the Taxes (in US$) of Seychelles in 1996?
Your answer should be compact. 4.29e+08. What is the difference between the Taxes (in US$) in Moldova in 1995 and the Taxes (in US$) in Spain in 1996?
Your answer should be very brief. -3.72e+1. What is the difference between the Taxes (in US$) in Seychelles in 1995 and the Taxes (in US$) in Spain in 1996?
Your answer should be very brief. -3.77e+1. What is the difference between the Taxes (in US$) of Algeria in 1995 and the Taxes (in US$) of Moldova in 1997?
Offer a terse response. 1.79e+11. What is the difference between the Taxes (in US$) of Algeria in 1995 and the Taxes (in US$) of Seychelles in 1997?
Keep it short and to the point. 1.80e+11. What is the difference between the Taxes (in US$) of Algeria in 1995 and the Taxes (in US$) of Spain in 1997?
Keep it short and to the point. 1.38e+11. What is the difference between the Taxes (in US$) of Moldova in 1995 and the Taxes (in US$) of Seychelles in 1997?
Provide a succinct answer. 4.14e+08. What is the difference between the Taxes (in US$) in Moldova in 1995 and the Taxes (in US$) in Spain in 1997?
Your response must be concise. -4.20e+1. What is the difference between the Taxes (in US$) in Seychelles in 1995 and the Taxes (in US$) in Spain in 1997?
Keep it short and to the point. -4.24e+1. What is the difference between the Taxes (in US$) of Algeria in 1996 and the Taxes (in US$) of Moldova in 1997?
Offer a very short reply. 2.08e+11. What is the difference between the Taxes (in US$) in Algeria in 1996 and the Taxes (in US$) in Seychelles in 1997?
Your answer should be compact. 2.09e+11. What is the difference between the Taxes (in US$) in Algeria in 1996 and the Taxes (in US$) in Spain in 1997?
Make the answer very short. 1.66e+11. What is the difference between the Taxes (in US$) of Moldova in 1996 and the Taxes (in US$) of Seychelles in 1997?
Offer a very short reply. 6.50e+08. What is the difference between the Taxes (in US$) of Moldova in 1996 and the Taxes (in US$) of Spain in 1997?
Your answer should be very brief. -4.18e+1. What is the difference between the Taxes (in US$) of Seychelles in 1996 and the Taxes (in US$) of Spain in 1997?
Provide a succinct answer. -4.24e+1. What is the average Taxes (in US$) of Algeria per year?
Provide a short and direct response. 1.28e+11. What is the average Taxes (in US$) of Moldova per year?
Your response must be concise. 4.20e+08. What is the average Taxes (in US$) of Seychelles per year?
Make the answer very short. 4.27e+08. What is the average Taxes (in US$) of Spain per year?
Offer a very short reply. 3.28e+1. In the year 1990, what is the difference between the Taxes (in US$) of Algeria and Taxes (in US$) of Moldova?
Offer a terse response. 4.78e+1. In the year 1990, what is the difference between the Taxes (in US$) of Algeria and Taxes (in US$) of Seychelles?
Provide a short and direct response. 4.73e+1. In the year 1990, what is the difference between the Taxes (in US$) in Algeria and Taxes (in US$) in Spain?
Offer a very short reply. 2.19e+1. In the year 1990, what is the difference between the Taxes (in US$) in Moldova and Taxes (in US$) in Seychelles?
Make the answer very short. -4.65e+08. In the year 1990, what is the difference between the Taxes (in US$) in Moldova and Taxes (in US$) in Spain?
Make the answer very short. -2.59e+1. In the year 1990, what is the difference between the Taxes (in US$) in Seychelles and Taxes (in US$) in Spain?
Offer a terse response. -2.54e+1. In the year 1991, what is the difference between the Taxes (in US$) in Algeria and Taxes (in US$) in Moldova?
Make the answer very short. 7.83e+1. In the year 1991, what is the difference between the Taxes (in US$) in Algeria and Taxes (in US$) in Seychelles?
Your response must be concise. 7.79e+1. In the year 1991, what is the difference between the Taxes (in US$) of Algeria and Taxes (in US$) of Spain?
Give a very brief answer. 5.04e+1. In the year 1991, what is the difference between the Taxes (in US$) in Moldova and Taxes (in US$) in Seychelles?
Make the answer very short. -4.34e+08. In the year 1991, what is the difference between the Taxes (in US$) in Moldova and Taxes (in US$) in Spain?
Your answer should be compact. -2.79e+1. In the year 1991, what is the difference between the Taxes (in US$) in Seychelles and Taxes (in US$) in Spain?
Provide a short and direct response. -2.75e+1. In the year 1992, what is the difference between the Taxes (in US$) in Algeria and Taxes (in US$) in Moldova?
Your response must be concise. 8.01e+1. In the year 1992, what is the difference between the Taxes (in US$) in Algeria and Taxes (in US$) in Seychelles?
Keep it short and to the point. 7.96e+1. In the year 1992, what is the difference between the Taxes (in US$) in Algeria and Taxes (in US$) in Spain?
Ensure brevity in your answer.  4.82e+1. In the year 1992, what is the difference between the Taxes (in US$) of Moldova and Taxes (in US$) of Seychelles?
Give a very brief answer. -5.22e+08. In the year 1992, what is the difference between the Taxes (in US$) of Moldova and Taxes (in US$) of Spain?
Provide a short and direct response. -3.19e+1. In the year 1992, what is the difference between the Taxes (in US$) of Seychelles and Taxes (in US$) of Spain?
Make the answer very short. -3.14e+1. In the year 1993, what is the difference between the Taxes (in US$) in Algeria and Taxes (in US$) in Moldova?
Your response must be concise. 8.63e+1. In the year 1993, what is the difference between the Taxes (in US$) of Algeria and Taxes (in US$) of Seychelles?
Your answer should be compact. 8.58e+1. In the year 1993, what is the difference between the Taxes (in US$) in Algeria and Taxes (in US$) in Spain?
Your answer should be very brief. 5.75e+1. In the year 1993, what is the difference between the Taxes (in US$) of Moldova and Taxes (in US$) of Seychelles?
Offer a terse response. -5.70e+08. In the year 1993, what is the difference between the Taxes (in US$) in Moldova and Taxes (in US$) in Spain?
Make the answer very short. -2.88e+1. In the year 1993, what is the difference between the Taxes (in US$) of Seychelles and Taxes (in US$) of Spain?
Offer a terse response. -2.82e+1. In the year 1994, what is the difference between the Taxes (in US$) of Algeria and Taxes (in US$) of Moldova?
Make the answer very short. 1.22e+11. In the year 1994, what is the difference between the Taxes (in US$) in Algeria and Taxes (in US$) in Seychelles?
Your answer should be compact. 1.22e+11. In the year 1994, what is the difference between the Taxes (in US$) of Algeria and Taxes (in US$) of Spain?
Your answer should be compact. 9.03e+1. In the year 1994, what is the difference between the Taxes (in US$) in Moldova and Taxes (in US$) in Seychelles?
Provide a succinct answer. -8.75e+07. In the year 1994, what is the difference between the Taxes (in US$) of Moldova and Taxes (in US$) of Spain?
Provide a succinct answer. -3.19e+1. In the year 1994, what is the difference between the Taxes (in US$) in Seychelles and Taxes (in US$) in Spain?
Make the answer very short. -3.18e+1. In the year 1995, what is the difference between the Taxes (in US$) in Algeria and Taxes (in US$) in Moldova?
Keep it short and to the point. 1.80e+11. In the year 1995, what is the difference between the Taxes (in US$) of Algeria and Taxes (in US$) of Seychelles?
Offer a very short reply. 1.80e+11. In the year 1995, what is the difference between the Taxes (in US$) of Algeria and Taxes (in US$) of Spain?
Keep it short and to the point. 1.46e+11. In the year 1995, what is the difference between the Taxes (in US$) in Moldova and Taxes (in US$) in Seychelles?
Provide a short and direct response. 4.34e+08. In the year 1995, what is the difference between the Taxes (in US$) in Moldova and Taxes (in US$) in Spain?
Ensure brevity in your answer.  -3.38e+1. In the year 1995, what is the difference between the Taxes (in US$) in Seychelles and Taxes (in US$) in Spain?
Offer a terse response. -3.43e+1. In the year 1996, what is the difference between the Taxes (in US$) in Algeria and Taxes (in US$) in Moldova?
Provide a succinct answer. 2.08e+11. In the year 1996, what is the difference between the Taxes (in US$) of Algeria and Taxes (in US$) of Seychelles?
Your answer should be very brief. 2.09e+11. In the year 1996, what is the difference between the Taxes (in US$) of Algeria and Taxes (in US$) of Spain?
Give a very brief answer. 1.71e+11. In the year 1996, what is the difference between the Taxes (in US$) in Moldova and Taxes (in US$) in Seychelles?
Your answer should be very brief. 6.65e+08. In the year 1996, what is the difference between the Taxes (in US$) of Moldova and Taxes (in US$) of Spain?
Your response must be concise. -3.70e+1. In the year 1996, what is the difference between the Taxes (in US$) in Seychelles and Taxes (in US$) in Spain?
Offer a terse response. -3.77e+1. In the year 1997, what is the difference between the Taxes (in US$) of Algeria and Taxes (in US$) of Moldova?
Ensure brevity in your answer.  2.19e+11. In the year 1997, what is the difference between the Taxes (in US$) of Algeria and Taxes (in US$) of Seychelles?
Give a very brief answer. 2.20e+11. In the year 1997, what is the difference between the Taxes (in US$) in Algeria and Taxes (in US$) in Spain?
Your response must be concise. 1.78e+11. In the year 1997, what is the difference between the Taxes (in US$) in Moldova and Taxes (in US$) in Seychelles?
Ensure brevity in your answer.  9.31e+08. In the year 1997, what is the difference between the Taxes (in US$) of Moldova and Taxes (in US$) of Spain?
Ensure brevity in your answer.  -4.15e+1. In the year 1997, what is the difference between the Taxes (in US$) of Seychelles and Taxes (in US$) of Spain?
Keep it short and to the point. -4.24e+1. What is the ratio of the Taxes (in US$) of Algeria in 1990 to that in 1991?
Keep it short and to the point. 0.61. What is the ratio of the Taxes (in US$) of Moldova in 1990 to that in 1991?
Give a very brief answer. 0.28. What is the ratio of the Taxes (in US$) in Seychelles in 1990 to that in 1991?
Your response must be concise. 1.07. What is the ratio of the Taxes (in US$) of Spain in 1990 to that in 1991?
Offer a very short reply. 0.93. What is the ratio of the Taxes (in US$) of Algeria in 1990 to that in 1992?
Ensure brevity in your answer.  0.6. What is the ratio of the Taxes (in US$) of Moldova in 1990 to that in 1992?
Give a very brief answer. 0.05. What is the ratio of the Taxes (in US$) in Seychelles in 1990 to that in 1992?
Offer a terse response. 0.87. What is the ratio of the Taxes (in US$) of Spain in 1990 to that in 1992?
Give a very brief answer. 0.81. What is the ratio of the Taxes (in US$) of Algeria in 1990 to that in 1993?
Give a very brief answer. 0.55. What is the ratio of the Taxes (in US$) in Moldova in 1990 to that in 1993?
Provide a short and direct response. 0.01. What is the ratio of the Taxes (in US$) of Seychelles in 1990 to that in 1993?
Offer a terse response. 0.73. What is the ratio of the Taxes (in US$) of Spain in 1990 to that in 1993?
Make the answer very short. 0.9. What is the ratio of the Taxes (in US$) of Algeria in 1990 to that in 1994?
Offer a very short reply. 0.39. What is the ratio of the Taxes (in US$) of Moldova in 1990 to that in 1994?
Your answer should be very brief. 0. What is the ratio of the Taxes (in US$) in Seychelles in 1990 to that in 1994?
Give a very brief answer. 1.17. What is the ratio of the Taxes (in US$) of Spain in 1990 to that in 1994?
Provide a short and direct response. 0.8. What is the ratio of the Taxes (in US$) of Algeria in 1990 to that in 1995?
Your answer should be very brief. 0.26. What is the ratio of the Taxes (in US$) in Seychelles in 1990 to that in 1995?
Your answer should be compact. 1.54. What is the ratio of the Taxes (in US$) in Spain in 1990 to that in 1995?
Offer a very short reply. 0.75. What is the ratio of the Taxes (in US$) in Algeria in 1990 to that in 1996?
Keep it short and to the point. 0.23. What is the ratio of the Taxes (in US$) of Moldova in 1990 to that in 1996?
Make the answer very short. 0. What is the ratio of the Taxes (in US$) in Seychelles in 1990 to that in 1996?
Provide a short and direct response. 1.52. What is the ratio of the Taxes (in US$) in Spain in 1990 to that in 1996?
Provide a succinct answer. 0.68. What is the ratio of the Taxes (in US$) of Algeria in 1990 to that in 1997?
Your answer should be compact. 0.22. What is the ratio of the Taxes (in US$) of Moldova in 1990 to that in 1997?
Offer a terse response. 0. What is the ratio of the Taxes (in US$) of Seychelles in 1990 to that in 1997?
Ensure brevity in your answer.  1.45. What is the ratio of the Taxes (in US$) of Spain in 1990 to that in 1997?
Your answer should be very brief. 0.6. What is the ratio of the Taxes (in US$) of Algeria in 1991 to that in 1992?
Give a very brief answer. 0.98. What is the ratio of the Taxes (in US$) of Seychelles in 1991 to that in 1992?
Ensure brevity in your answer.  0.81. What is the ratio of the Taxes (in US$) in Spain in 1991 to that in 1992?
Your answer should be compact. 0.88. What is the ratio of the Taxes (in US$) in Algeria in 1991 to that in 1993?
Your response must be concise. 0.91. What is the ratio of the Taxes (in US$) in Moldova in 1991 to that in 1993?
Offer a terse response. 0.03. What is the ratio of the Taxes (in US$) in Seychelles in 1991 to that in 1993?
Provide a succinct answer. 0.68. What is the ratio of the Taxes (in US$) in Spain in 1991 to that in 1993?
Your response must be concise. 0.97. What is the ratio of the Taxes (in US$) of Algeria in 1991 to that in 1994?
Provide a succinct answer. 0.64. What is the ratio of the Taxes (in US$) of Moldova in 1991 to that in 1994?
Provide a succinct answer. 0.01. What is the ratio of the Taxes (in US$) in Seychelles in 1991 to that in 1994?
Keep it short and to the point. 1.09. What is the ratio of the Taxes (in US$) of Spain in 1991 to that in 1994?
Give a very brief answer. 0.87. What is the ratio of the Taxes (in US$) in Algeria in 1991 to that in 1995?
Provide a short and direct response. 0.43. What is the ratio of the Taxes (in US$) of Moldova in 1991 to that in 1995?
Give a very brief answer. 0. What is the ratio of the Taxes (in US$) in Seychelles in 1991 to that in 1995?
Ensure brevity in your answer.  1.45. What is the ratio of the Taxes (in US$) in Spain in 1991 to that in 1995?
Your answer should be compact. 0.81. What is the ratio of the Taxes (in US$) in Algeria in 1991 to that in 1996?
Keep it short and to the point. 0.37. What is the ratio of the Taxes (in US$) in Moldova in 1991 to that in 1996?
Ensure brevity in your answer.  0. What is the ratio of the Taxes (in US$) of Seychelles in 1991 to that in 1996?
Make the answer very short. 1.43. What is the ratio of the Taxes (in US$) of Spain in 1991 to that in 1996?
Make the answer very short. 0.74. What is the ratio of the Taxes (in US$) of Algeria in 1991 to that in 1997?
Provide a short and direct response. 0.35. What is the ratio of the Taxes (in US$) in Moldova in 1991 to that in 1997?
Make the answer very short. 0. What is the ratio of the Taxes (in US$) of Seychelles in 1991 to that in 1997?
Your answer should be compact. 1.36. What is the ratio of the Taxes (in US$) in Spain in 1991 to that in 1997?
Offer a terse response. 0.65. What is the ratio of the Taxes (in US$) of Algeria in 1992 to that in 1993?
Give a very brief answer. 0.93. What is the ratio of the Taxes (in US$) of Moldova in 1992 to that in 1993?
Keep it short and to the point. 0.21. What is the ratio of the Taxes (in US$) in Seychelles in 1992 to that in 1993?
Your answer should be compact. 0.84. What is the ratio of the Taxes (in US$) of Spain in 1992 to that in 1993?
Your answer should be compact. 1.11. What is the ratio of the Taxes (in US$) of Algeria in 1992 to that in 1994?
Make the answer very short. 0.65. What is the ratio of the Taxes (in US$) of Moldova in 1992 to that in 1994?
Make the answer very short. 0.05. What is the ratio of the Taxes (in US$) of Seychelles in 1992 to that in 1994?
Your response must be concise. 1.35. What is the ratio of the Taxes (in US$) in Spain in 1992 to that in 1994?
Ensure brevity in your answer.  0.99. What is the ratio of the Taxes (in US$) of Algeria in 1992 to that in 1995?
Offer a very short reply. 0.44. What is the ratio of the Taxes (in US$) in Moldova in 1992 to that in 1995?
Make the answer very short. 0.02. What is the ratio of the Taxes (in US$) in Seychelles in 1992 to that in 1995?
Keep it short and to the point. 1.78. What is the ratio of the Taxes (in US$) of Spain in 1992 to that in 1995?
Ensure brevity in your answer.  0.92. What is the ratio of the Taxes (in US$) in Algeria in 1992 to that in 1996?
Your response must be concise. 0.38. What is the ratio of the Taxes (in US$) of Moldova in 1992 to that in 1996?
Your response must be concise. 0.02. What is the ratio of the Taxes (in US$) of Seychelles in 1992 to that in 1996?
Keep it short and to the point. 1.75. What is the ratio of the Taxes (in US$) of Spain in 1992 to that in 1996?
Provide a succinct answer. 0.84. What is the ratio of the Taxes (in US$) of Algeria in 1992 to that in 1997?
Make the answer very short. 0.36. What is the ratio of the Taxes (in US$) in Moldova in 1992 to that in 1997?
Your response must be concise. 0.01. What is the ratio of the Taxes (in US$) in Seychelles in 1992 to that in 1997?
Your response must be concise. 1.67. What is the ratio of the Taxes (in US$) in Spain in 1992 to that in 1997?
Your response must be concise. 0.75. What is the ratio of the Taxes (in US$) of Algeria in 1993 to that in 1994?
Your response must be concise. 0.71. What is the ratio of the Taxes (in US$) in Moldova in 1993 to that in 1994?
Ensure brevity in your answer.  0.23. What is the ratio of the Taxes (in US$) in Seychelles in 1993 to that in 1994?
Make the answer very short. 1.61. What is the ratio of the Taxes (in US$) in Spain in 1993 to that in 1994?
Make the answer very short. 0.9. What is the ratio of the Taxes (in US$) in Algeria in 1993 to that in 1995?
Offer a very short reply. 0.48. What is the ratio of the Taxes (in US$) in Moldova in 1993 to that in 1995?
Offer a very short reply. 0.1. What is the ratio of the Taxes (in US$) of Seychelles in 1993 to that in 1995?
Ensure brevity in your answer.  2.13. What is the ratio of the Taxes (in US$) of Spain in 1993 to that in 1995?
Offer a terse response. 0.84. What is the ratio of the Taxes (in US$) in Algeria in 1993 to that in 1996?
Your answer should be compact. 0.41. What is the ratio of the Taxes (in US$) in Moldova in 1993 to that in 1996?
Keep it short and to the point. 0.08. What is the ratio of the Taxes (in US$) of Seychelles in 1993 to that in 1996?
Offer a very short reply. 2.1. What is the ratio of the Taxes (in US$) in Spain in 1993 to that in 1996?
Your response must be concise. 0.76. What is the ratio of the Taxes (in US$) in Algeria in 1993 to that in 1997?
Provide a short and direct response. 0.39. What is the ratio of the Taxes (in US$) of Moldova in 1993 to that in 1997?
Your answer should be compact. 0.06. What is the ratio of the Taxes (in US$) of Seychelles in 1993 to that in 1997?
Make the answer very short. 2. What is the ratio of the Taxes (in US$) in Spain in 1993 to that in 1997?
Provide a succinct answer. 0.68. What is the ratio of the Taxes (in US$) in Algeria in 1994 to that in 1995?
Offer a very short reply. 0.68. What is the ratio of the Taxes (in US$) of Moldova in 1994 to that in 1995?
Make the answer very short. 0.42. What is the ratio of the Taxes (in US$) in Seychelles in 1994 to that in 1995?
Provide a short and direct response. 1.32. What is the ratio of the Taxes (in US$) in Spain in 1994 to that in 1995?
Make the answer very short. 0.93. What is the ratio of the Taxes (in US$) in Algeria in 1994 to that in 1996?
Provide a succinct answer. 0.59. What is the ratio of the Taxes (in US$) of Moldova in 1994 to that in 1996?
Give a very brief answer. 0.32. What is the ratio of the Taxes (in US$) in Seychelles in 1994 to that in 1996?
Your answer should be very brief. 1.3. What is the ratio of the Taxes (in US$) of Spain in 1994 to that in 1996?
Offer a terse response. 0.85. What is the ratio of the Taxes (in US$) of Algeria in 1994 to that in 1997?
Make the answer very short. 0.56. What is the ratio of the Taxes (in US$) of Moldova in 1994 to that in 1997?
Your answer should be very brief. 0.25. What is the ratio of the Taxes (in US$) in Seychelles in 1994 to that in 1997?
Your response must be concise. 1.24. What is the ratio of the Taxes (in US$) in Spain in 1994 to that in 1997?
Provide a short and direct response. 0.75. What is the ratio of the Taxes (in US$) in Algeria in 1995 to that in 1996?
Offer a terse response. 0.86. What is the ratio of the Taxes (in US$) in Moldova in 1995 to that in 1996?
Keep it short and to the point. 0.76. What is the ratio of the Taxes (in US$) of Spain in 1995 to that in 1996?
Ensure brevity in your answer.  0.91. What is the ratio of the Taxes (in US$) in Algeria in 1995 to that in 1997?
Your answer should be very brief. 0.82. What is the ratio of the Taxes (in US$) of Moldova in 1995 to that in 1997?
Your answer should be compact. 0.59. What is the ratio of the Taxes (in US$) in Seychelles in 1995 to that in 1997?
Your answer should be compact. 0.94. What is the ratio of the Taxes (in US$) in Spain in 1995 to that in 1997?
Your response must be concise. 0.81. What is the ratio of the Taxes (in US$) of Moldova in 1996 to that in 1997?
Ensure brevity in your answer.  0.78. What is the ratio of the Taxes (in US$) of Seychelles in 1996 to that in 1997?
Ensure brevity in your answer.  0.95. What is the ratio of the Taxes (in US$) of Spain in 1996 to that in 1997?
Your answer should be very brief. 0.89. What is the difference between the highest and the second highest Taxes (in US$) in Algeria?
Offer a terse response. 1.16e+1. What is the difference between the highest and the second highest Taxes (in US$) in Moldova?
Provide a succinct answer. 2.81e+08. What is the difference between the highest and the second highest Taxes (in US$) of Seychelles?
Your answer should be compact. 1.05e+08. What is the difference between the highest and the second highest Taxes (in US$) of Spain?
Provide a short and direct response. 4.78e+09. What is the difference between the highest and the lowest Taxes (in US$) in Algeria?
Ensure brevity in your answer.  1.73e+11. What is the difference between the highest and the lowest Taxes (in US$) in Moldova?
Your answer should be compact. 1.25e+09. What is the difference between the highest and the lowest Taxes (in US$) of Seychelles?
Your answer should be very brief. 3.41e+08. What is the difference between the highest and the lowest Taxes (in US$) of Spain?
Your answer should be compact. 1.69e+1. 